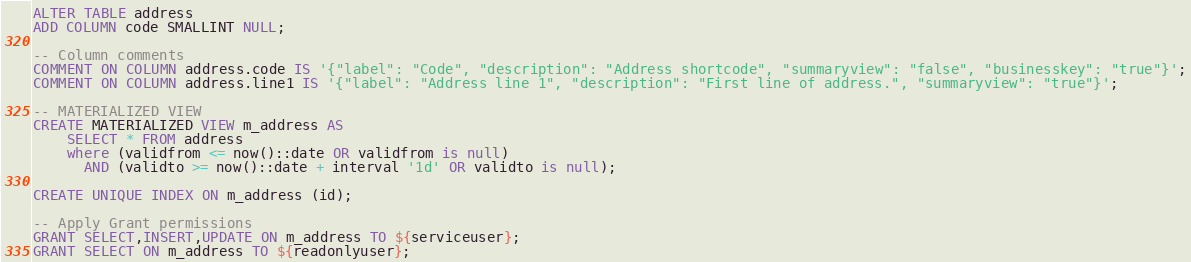Convert code to text. <code><loc_0><loc_0><loc_500><loc_500><_SQL_>ALTER TABLE address
ADD COLUMN code SMALLINT NULL;

-- Column comments
COMMENT ON COLUMN address.code IS '{"label": "Code", "description": "Address shortcode", "summaryview": "false", "businesskey": "true"}';
COMMENT ON COLUMN address.line1 IS '{"label": "Address line 1", "description": "First line of address.", "summaryview": "true"}';

-- MATERIALIZED VIEW
CREATE MATERIALIZED VIEW m_address AS
    SELECT * FROM address
    where (validfrom <= now()::date OR validfrom is null)
      AND (validto >= now()::date + interval '1d' OR validto is null);

CREATE UNIQUE INDEX ON m_address (id);

-- Apply Grant permissions
GRANT SELECT,INSERT,UPDATE ON m_address TO ${serviceuser};
GRANT SELECT ON m_address TO ${readonlyuser};
</code> 